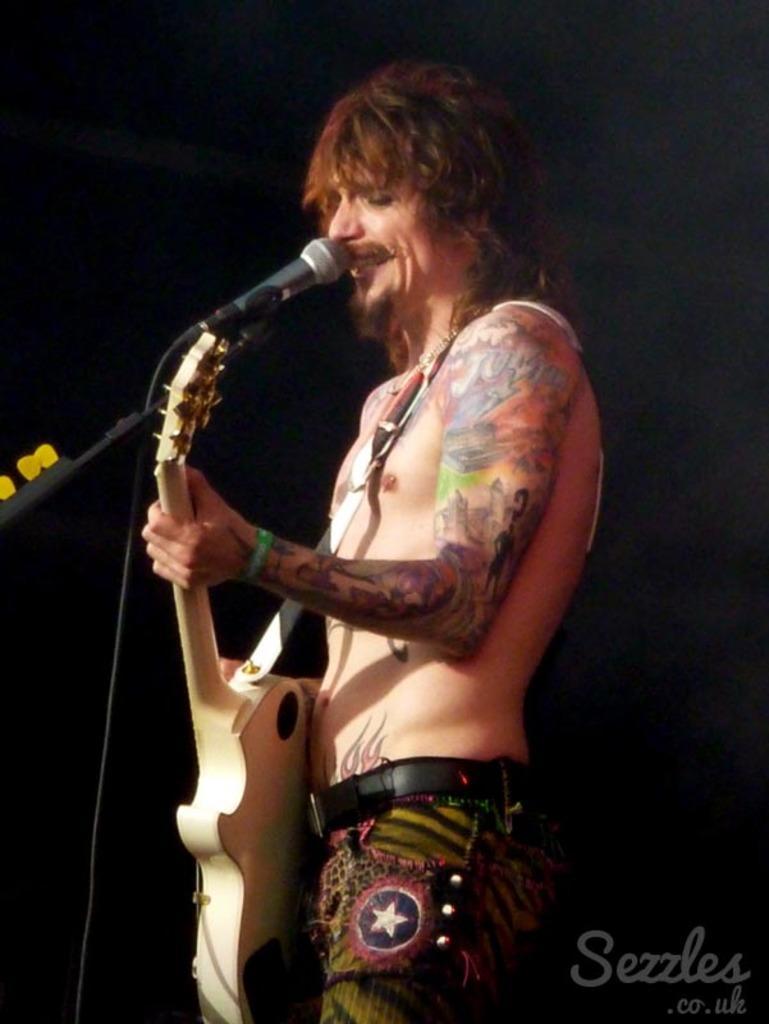Can you describe this image briefly? In this picture we can see a man who is playing guitar. And this is the mike. 